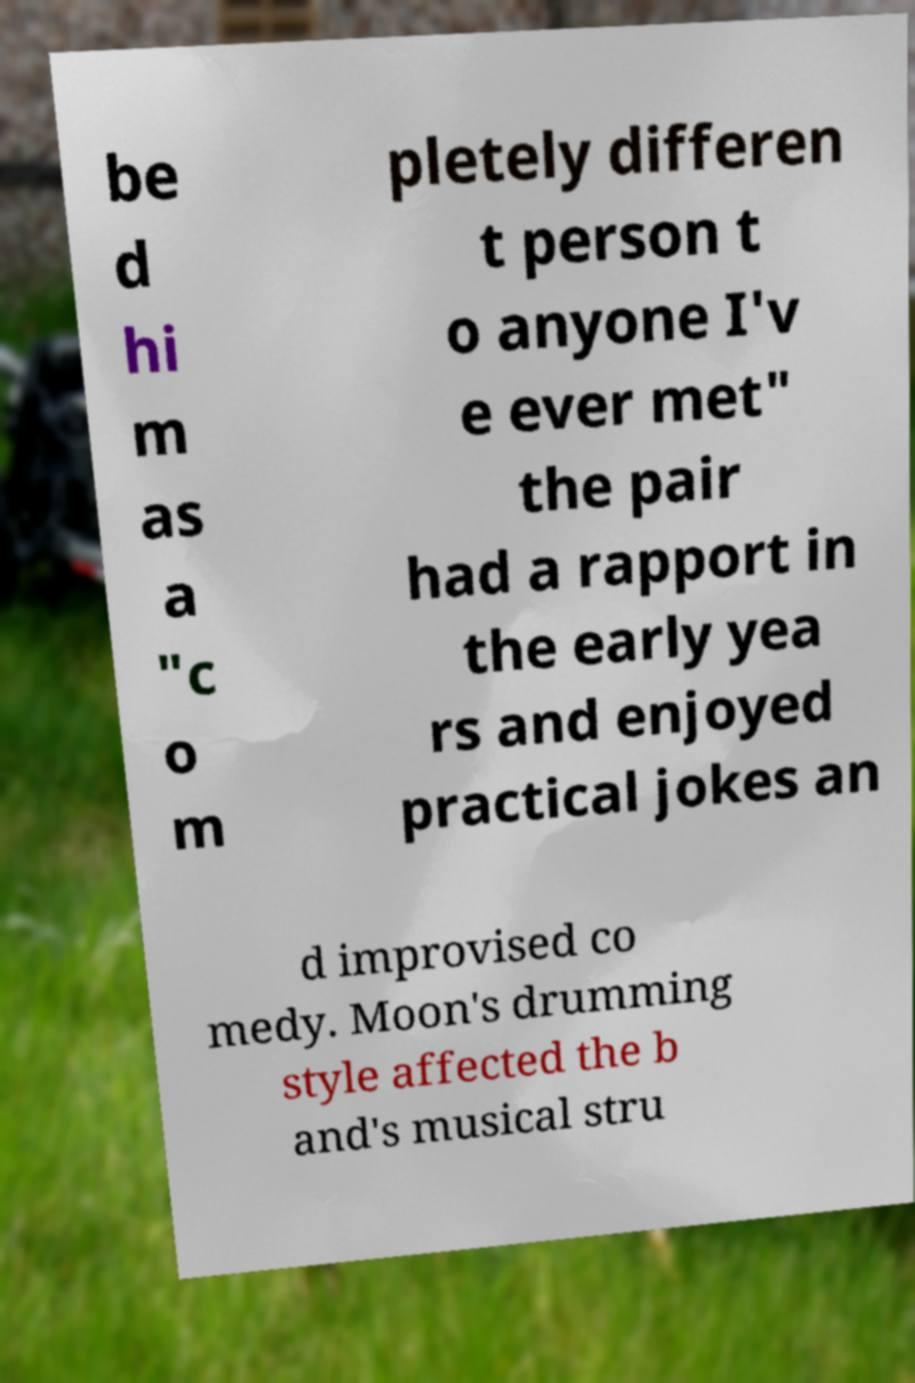There's text embedded in this image that I need extracted. Can you transcribe it verbatim? be d hi m as a "c o m pletely differen t person t o anyone I'v e ever met" the pair had a rapport in the early yea rs and enjoyed practical jokes an d improvised co medy. Moon's drumming style affected the b and's musical stru 